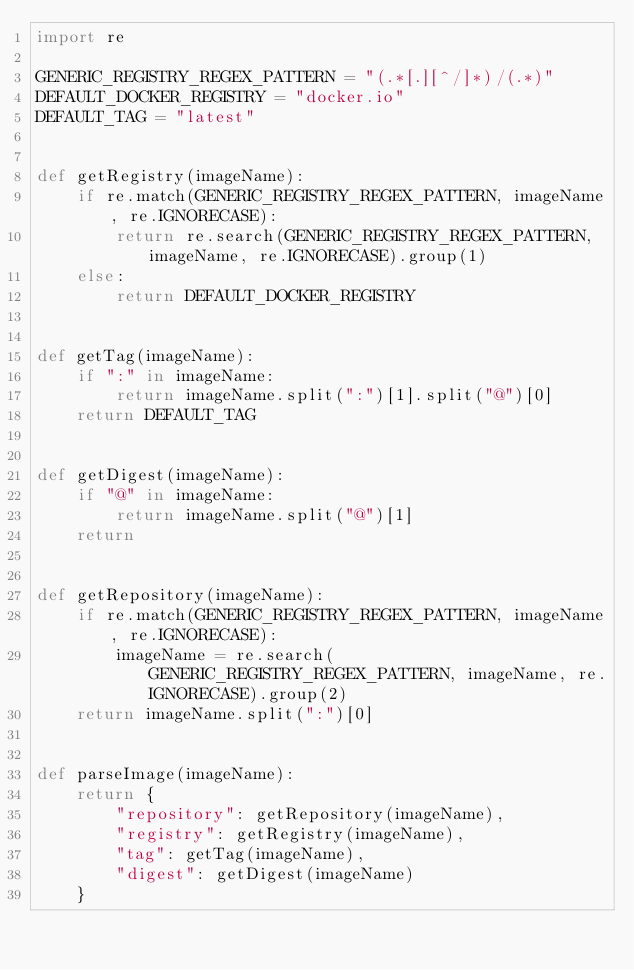Convert code to text. <code><loc_0><loc_0><loc_500><loc_500><_Python_>import re

GENERIC_REGISTRY_REGEX_PATTERN = "(.*[.][^/]*)/(.*)"
DEFAULT_DOCKER_REGISTRY = "docker.io"
DEFAULT_TAG = "latest"


def getRegistry(imageName):
    if re.match(GENERIC_REGISTRY_REGEX_PATTERN, imageName, re.IGNORECASE):
        return re.search(GENERIC_REGISTRY_REGEX_PATTERN, imageName, re.IGNORECASE).group(1)
    else:
        return DEFAULT_DOCKER_REGISTRY


def getTag(imageName):
    if ":" in imageName:
        return imageName.split(":")[1].split("@")[0]
    return DEFAULT_TAG


def getDigest(imageName):
    if "@" in imageName:
        return imageName.split("@")[1]
    return


def getRepository(imageName):
    if re.match(GENERIC_REGISTRY_REGEX_PATTERN, imageName, re.IGNORECASE):
        imageName = re.search(GENERIC_REGISTRY_REGEX_PATTERN, imageName, re.IGNORECASE).group(2)
    return imageName.split(":")[0]


def parseImage(imageName):
    return {
        "repository": getRepository(imageName),
        "registry": getRegistry(imageName),
        "tag": getTag(imageName),
        "digest": getDigest(imageName)
    }
</code> 